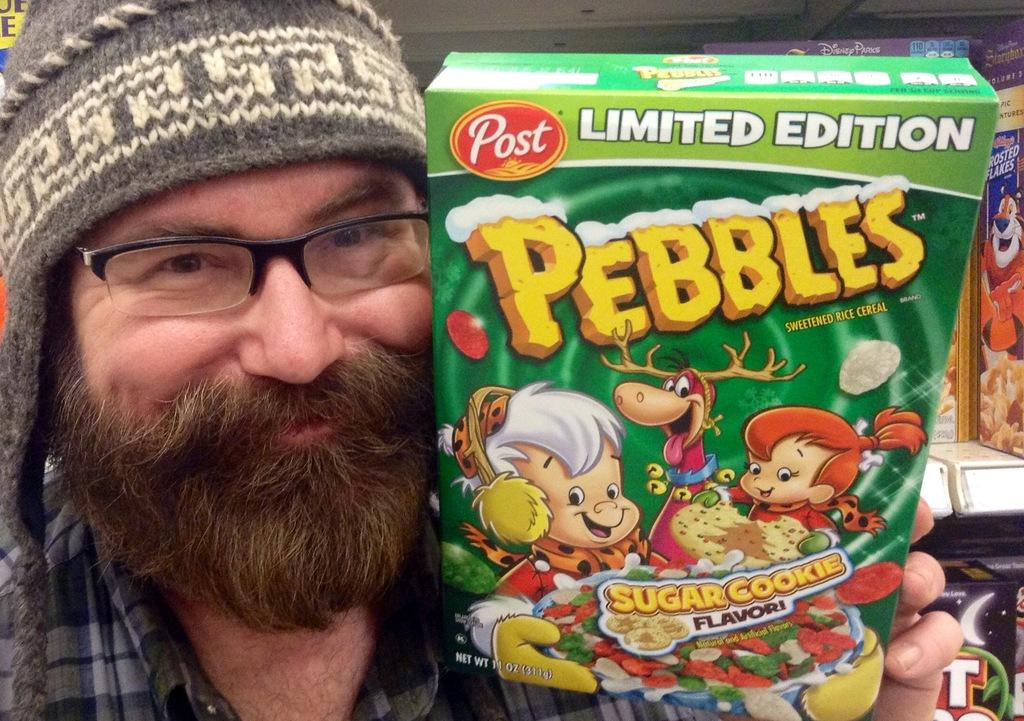What is the main subject of the image? There is a person in the image. What is the person holding or interacting with in the image? There is a food box in the image. Can you describe the background of the image? There are objects in the background of the image. How many feet can be seen in the image? There is no mention of feet or any body parts in the image, so it is not possible to determine the number of feet present. 